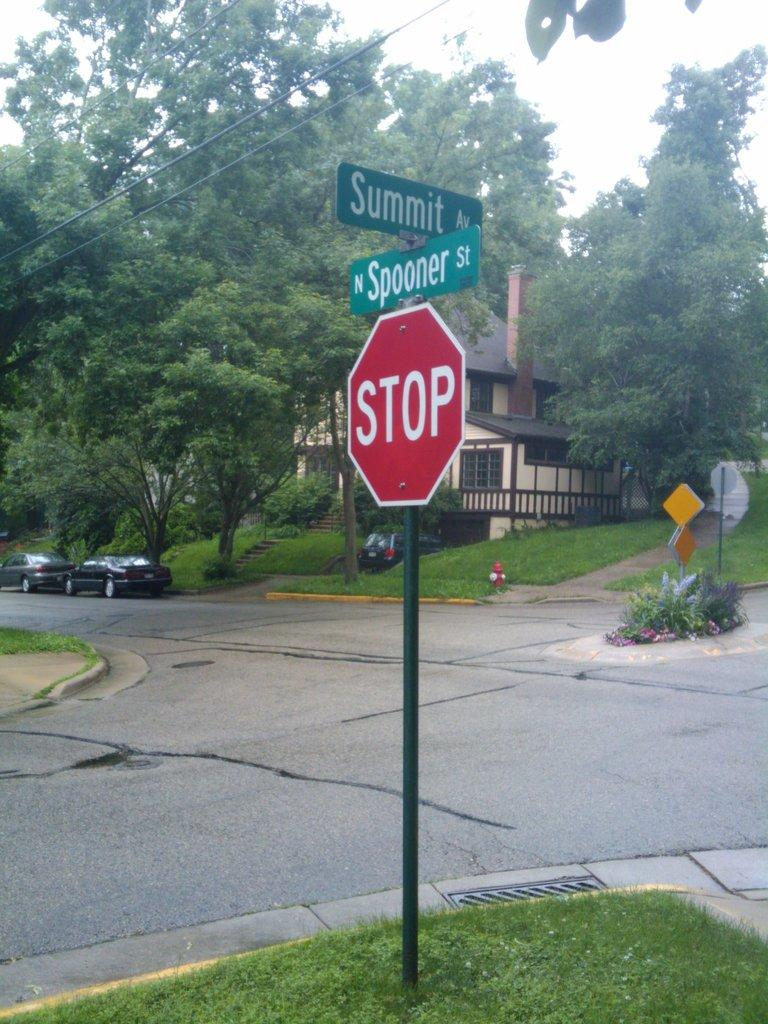<image>
Give a short and clear explanation of the subsequent image. a stop sign at the intersection of Spooner and Summit 